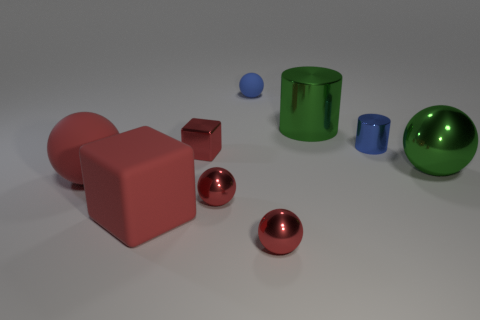Does the tiny matte thing have the same shape as the small blue object right of the blue matte sphere?
Give a very brief answer. No. There is a big ball that is the same color as the metal block; what is its material?
Your response must be concise. Rubber. Is there any other thing that has the same shape as the small blue shiny thing?
Your answer should be compact. Yes. Do the big red block and the red object that is behind the big matte sphere have the same material?
Ensure brevity in your answer.  No. What is the color of the metallic ball that is left of the blue rubber ball behind the blue object in front of the small rubber sphere?
Keep it short and to the point. Red. Are there any other things that are the same size as the blue sphere?
Ensure brevity in your answer.  Yes. There is a large cube; is it the same color as the large sphere on the right side of the small metallic block?
Provide a succinct answer. No. What color is the small shiny cylinder?
Your answer should be compact. Blue. What is the shape of the rubber thing to the left of the rubber cube left of the big object behind the large green metallic sphere?
Make the answer very short. Sphere. What number of other things are there of the same color as the tiny shiny cube?
Your answer should be compact. 4. 